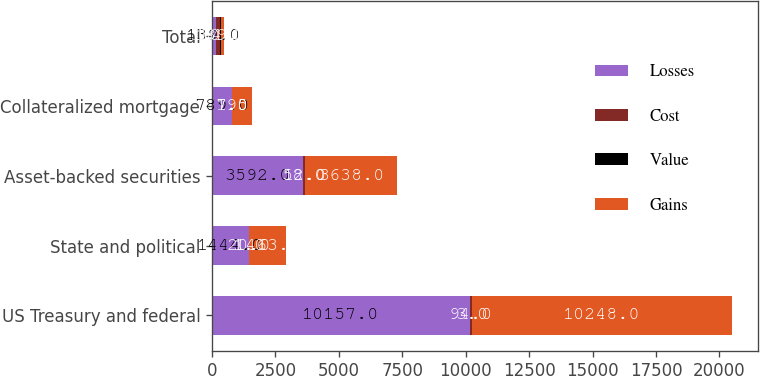<chart> <loc_0><loc_0><loc_500><loc_500><stacked_bar_chart><ecel><fcel>US Treasury and federal<fcel>State and political<fcel>Asset-backed securities<fcel>Collateralized mortgage<fcel>Total<nl><fcel>Losses<fcel>10157<fcel>1444<fcel>3592<fcel>789<fcel>139<nl><fcel>Cost<fcel>94<fcel>20<fcel>58<fcel>7<fcel>184<nl><fcel>Value<fcel>3<fcel>1<fcel>12<fcel>1<fcel>20<nl><fcel>Gains<fcel>10248<fcel>1463<fcel>3638<fcel>795<fcel>139<nl></chart> 